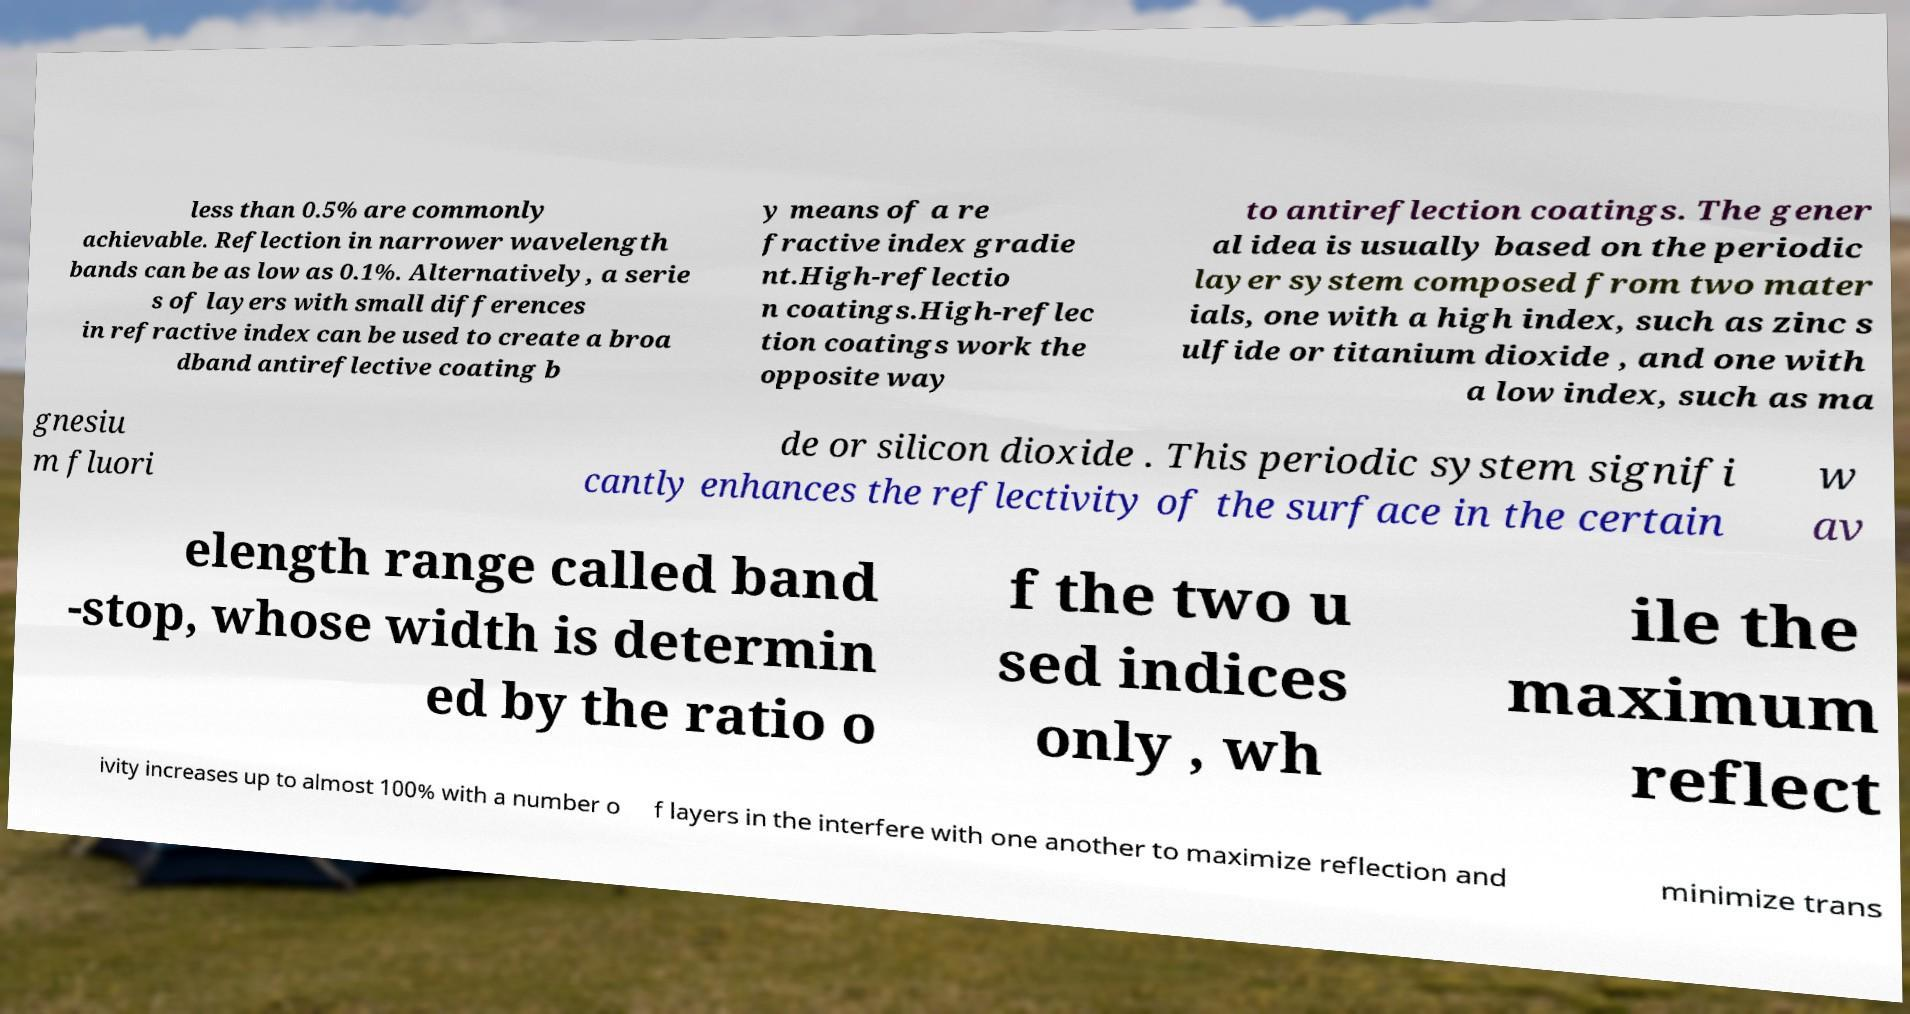There's text embedded in this image that I need extracted. Can you transcribe it verbatim? less than 0.5% are commonly achievable. Reflection in narrower wavelength bands can be as low as 0.1%. Alternatively, a serie s of layers with small differences in refractive index can be used to create a broa dband antireflective coating b y means of a re fractive index gradie nt.High-reflectio n coatings.High-reflec tion coatings work the opposite way to antireflection coatings. The gener al idea is usually based on the periodic layer system composed from two mater ials, one with a high index, such as zinc s ulfide or titanium dioxide , and one with a low index, such as ma gnesiu m fluori de or silicon dioxide . This periodic system signifi cantly enhances the reflectivity of the surface in the certain w av elength range called band -stop, whose width is determin ed by the ratio o f the two u sed indices only , wh ile the maximum reflect ivity increases up to almost 100% with a number o f layers in the interfere with one another to maximize reflection and minimize trans 